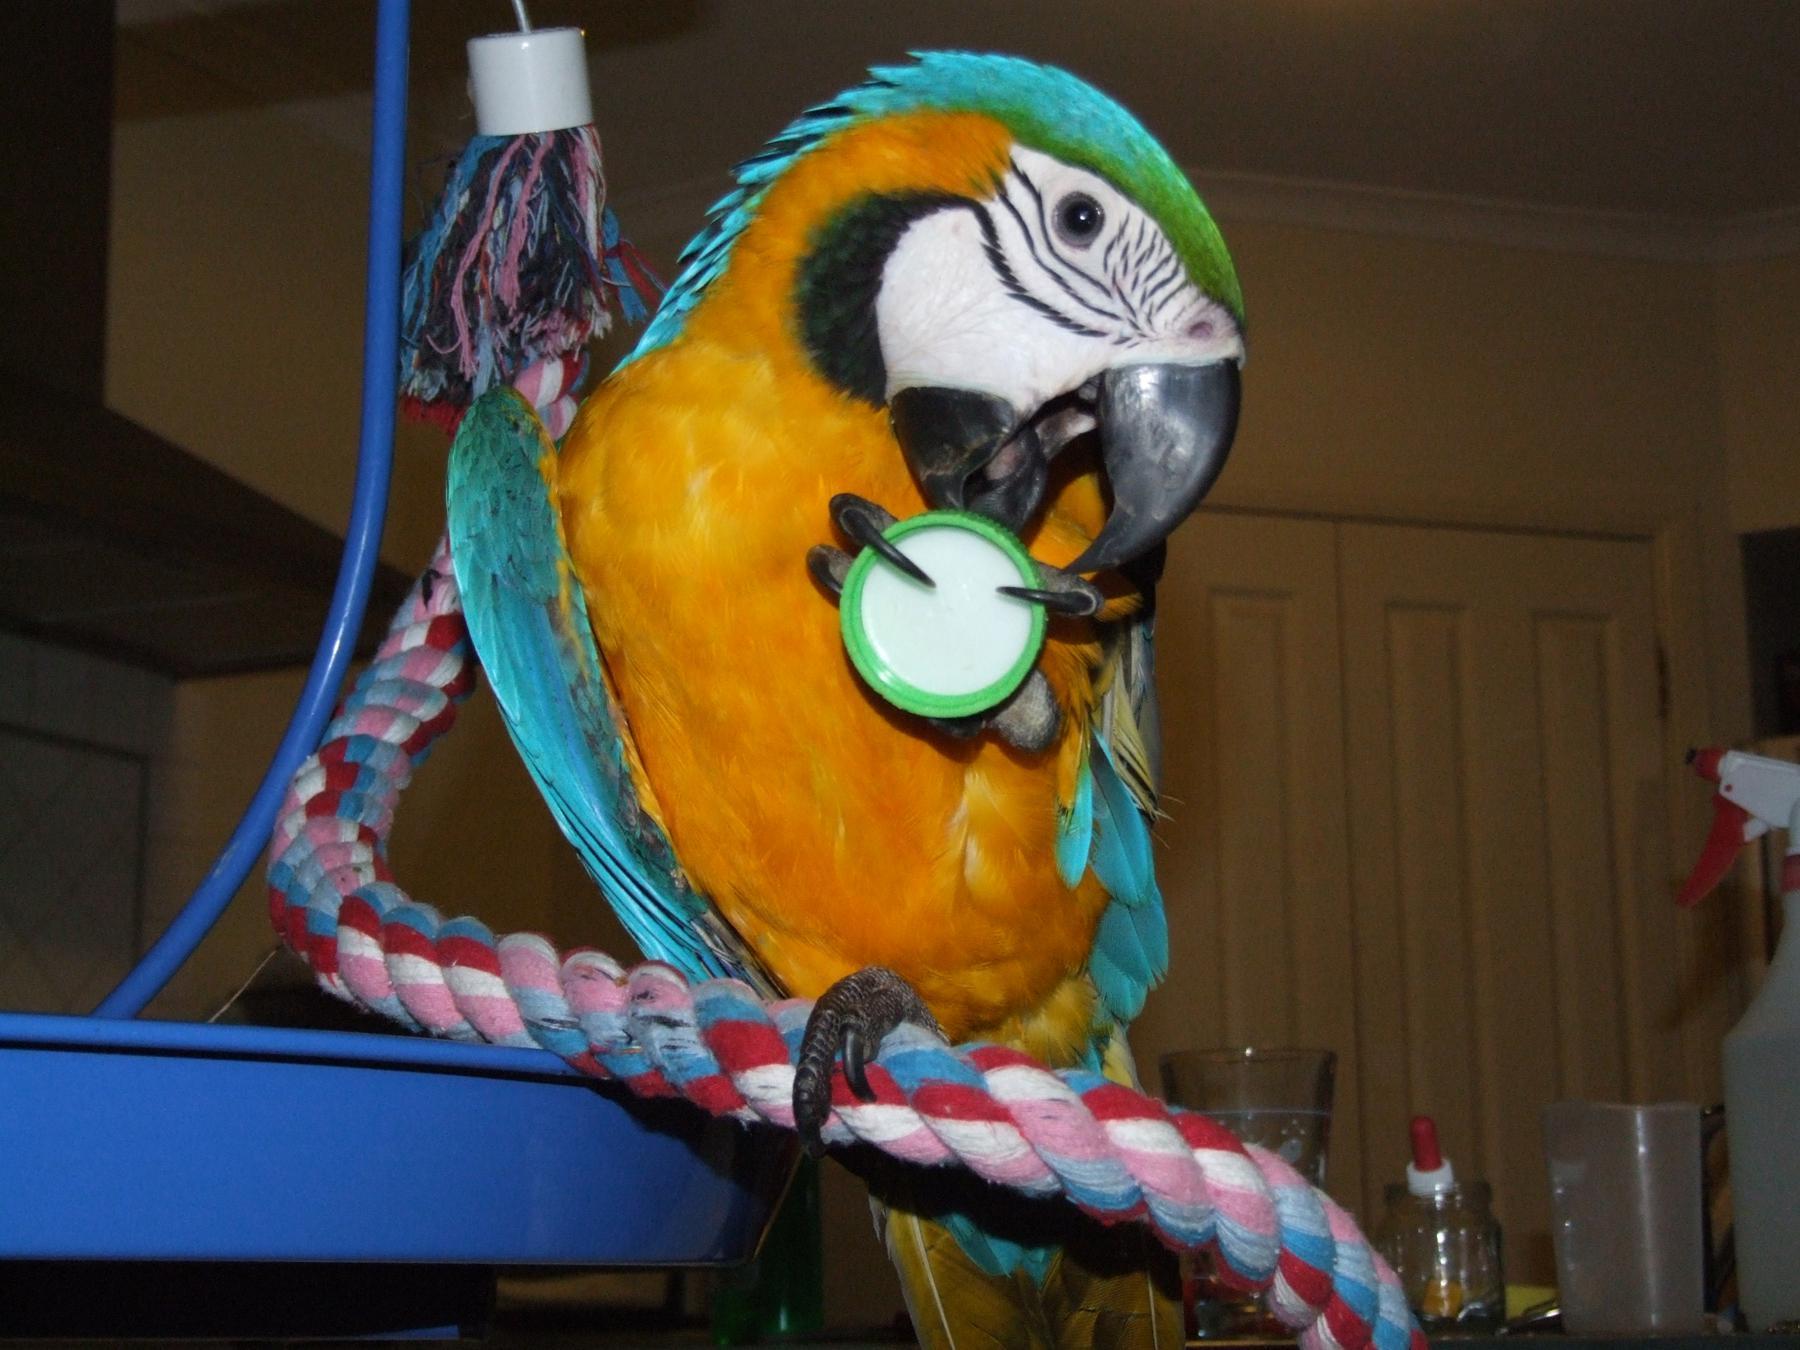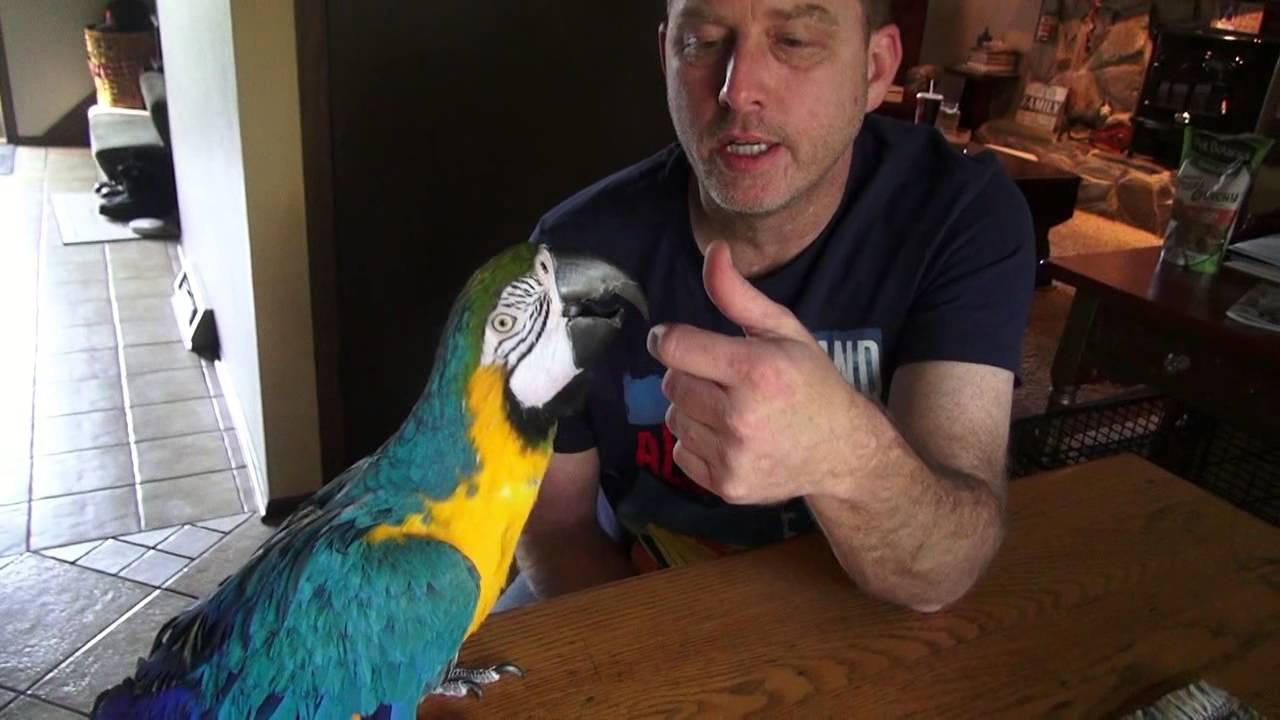The first image is the image on the left, the second image is the image on the right. Given the left and right images, does the statement "One of the humans visible is wearing a long-sleeved shirt." hold true? Answer yes or no. No. 